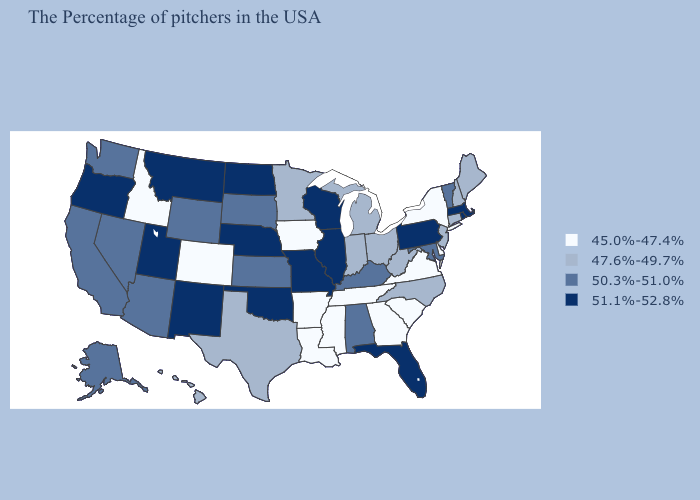Name the states that have a value in the range 50.3%-51.0%?
Concise answer only. Vermont, Maryland, Kentucky, Alabama, Kansas, South Dakota, Wyoming, Arizona, Nevada, California, Washington, Alaska. Among the states that border Wisconsin , does Illinois have the highest value?
Give a very brief answer. Yes. Does Utah have the lowest value in the USA?
Concise answer only. No. Among the states that border Montana , which have the highest value?
Answer briefly. North Dakota. What is the value of Delaware?
Be succinct. 45.0%-47.4%. Is the legend a continuous bar?
Write a very short answer. No. What is the value of South Dakota?
Be succinct. 50.3%-51.0%. What is the value of Indiana?
Short answer required. 47.6%-49.7%. What is the lowest value in states that border Vermont?
Quick response, please. 45.0%-47.4%. Name the states that have a value in the range 51.1%-52.8%?
Answer briefly. Massachusetts, Rhode Island, Pennsylvania, Florida, Wisconsin, Illinois, Missouri, Nebraska, Oklahoma, North Dakota, New Mexico, Utah, Montana, Oregon. What is the highest value in states that border Iowa?
Be succinct. 51.1%-52.8%. Does the first symbol in the legend represent the smallest category?
Quick response, please. Yes. What is the highest value in the Northeast ?
Write a very short answer. 51.1%-52.8%. What is the value of Idaho?
Answer briefly. 45.0%-47.4%. What is the lowest value in the USA?
Answer briefly. 45.0%-47.4%. 